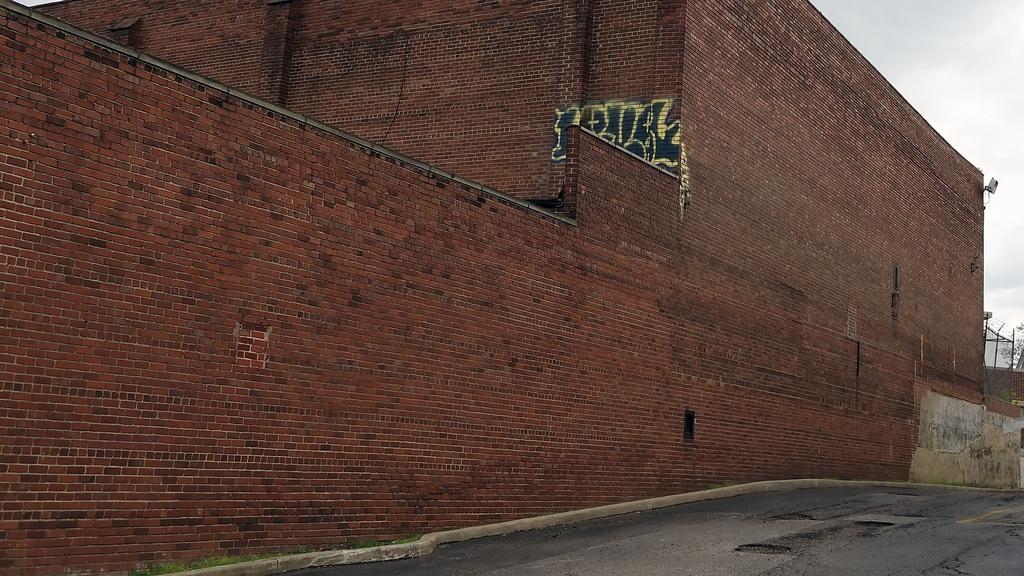Could you give a brief overview of what you see in this image? In this image at the bottom we can see a road. We can see drawings on the brick wall. On the right side we can see an object on the wall, branches of a tree, objects and clouds in the sky. 